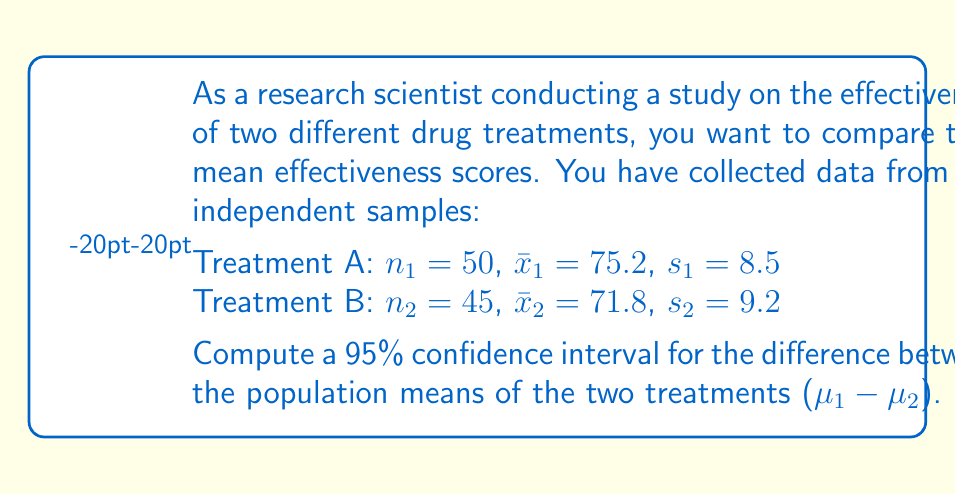Solve this math problem. To compute the confidence interval for the difference between two population means, we'll follow these steps:

1. Calculate the standard error of the difference:
   $$SE = \sqrt{\frac{s_1^2}{n_1} + \frac{s_2^2}{n_2}}$$
   $$SE = \sqrt{\frac{8.5^2}{50} + \frac{9.2^2}{45}} = \sqrt{1.445 + 1.882} = \sqrt{3.327} = 1.824$$

2. Determine the degrees of freedom (df) using the Welch–Satterthwaite equation:
   $$df = \frac{(\frac{s_1^2}{n_1} + \frac{s_2^2}{n_2})^2}{\frac{(s_1^2/n_1)^2}{n_1-1} + \frac{(s_2^2/n_2)^2}{n_2-1}}$$
   $$df = \frac{(1.445 + 1.882)^2}{\frac{1.445^2}{49} + \frac{1.882^2}{44}} = 91.65$$
   Round down to 91 for a conservative estimate.

3. Find the t-critical value for a 95% confidence interval with 91 df:
   $t_{0.025, 91} = 1.986$ (from t-distribution table)

4. Calculate the margin of error:
   $$ME = t_{0.025, 91} \times SE = 1.986 \times 1.824 = 3.622$$

5. Compute the difference between sample means:
   $$\bar{x}_1 - \bar{x}_2 = 75.2 - 71.8 = 3.4$$

6. Calculate the confidence interval:
   $$CI = (\bar{x}_1 - \bar{x}_2) \pm ME$$
   $$CI = 3.4 \pm 3.622$$
   $$CI = (-0.222, 7.022)$$
Answer: (-0.222, 7.022) 